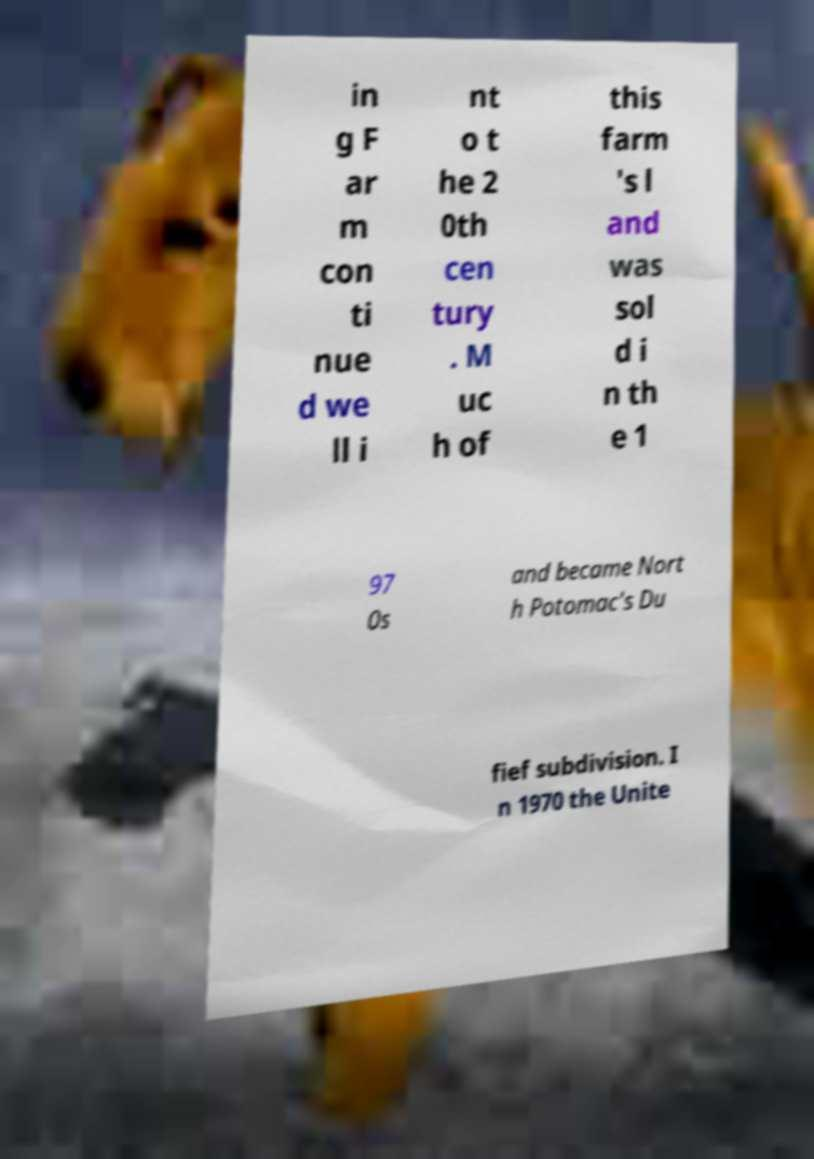What messages or text are displayed in this image? I need them in a readable, typed format. in g F ar m con ti nue d we ll i nt o t he 2 0th cen tury . M uc h of this farm 's l and was sol d i n th e 1 97 0s and became Nort h Potomac's Du fief subdivision. I n 1970 the Unite 